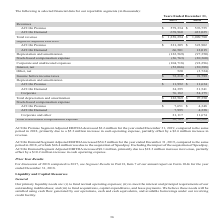According to Aci Worldwide's financial document, Why did ACI On Premise Segment Adjusted EBITDA decrease between 2018 and 2019? due to a $5.2 million increase in cash operating expense, partially offset by a $2.6 million increase in revenue.. The document states: "19, compared to the same period in 2018, primarily due to a $5.2 million increase in cash operating expense, partially offset by a $2.6 million increa..." Also, What was the total revenue in 2018? According to the financial document, $ 1,009,780 (in thousands). The relevant text states: "Total revenue $ 1,258,294 $ 1,009,780..." Also, What was the total stock-based compensation expense in 2019? According to the financial document, $ 36,763 (in thousands). The relevant text states: "Total stock-based compensation expense $ 36,763 $ 20,360..." Also, can you calculate: What was the change in Corporate depreciation and amortization between 2018 and 2019? Based on the calculation: 76,182-54,175, the result is 22007 (in thousands). This is based on the information: "Corporate 76,182 54,175 Corporate 76,182 54,175..." The key data points involved are: 54,175, 76,182. Also, can you calculate: What was the change in ACI on Premise revenues between 2018 and 2019? Based on the calculation: $579,334-$576,755, the result is 2579 (in thousands). This is based on the information: "ACI On Premise $ 579,334 $ 576,755 ACI On Premise $ 579,334 $ 576,755..." The key data points involved are: 576,755, 579,334. Also, can you calculate: What was the percentage change in segment adjusted EBITDA ACI on Premise between 2018 and 2019? To answer this question, I need to perform calculations using the financial data. The calculation is: ($321,305-$323,902)/$323,902, which equals -0.8 (percentage). This is based on the information: "ACI On Premise $ 321,305 $ 323,902 ACI On Premise $ 321,305 $ 323,902..." The key data points involved are: 321,305, 323,902. 